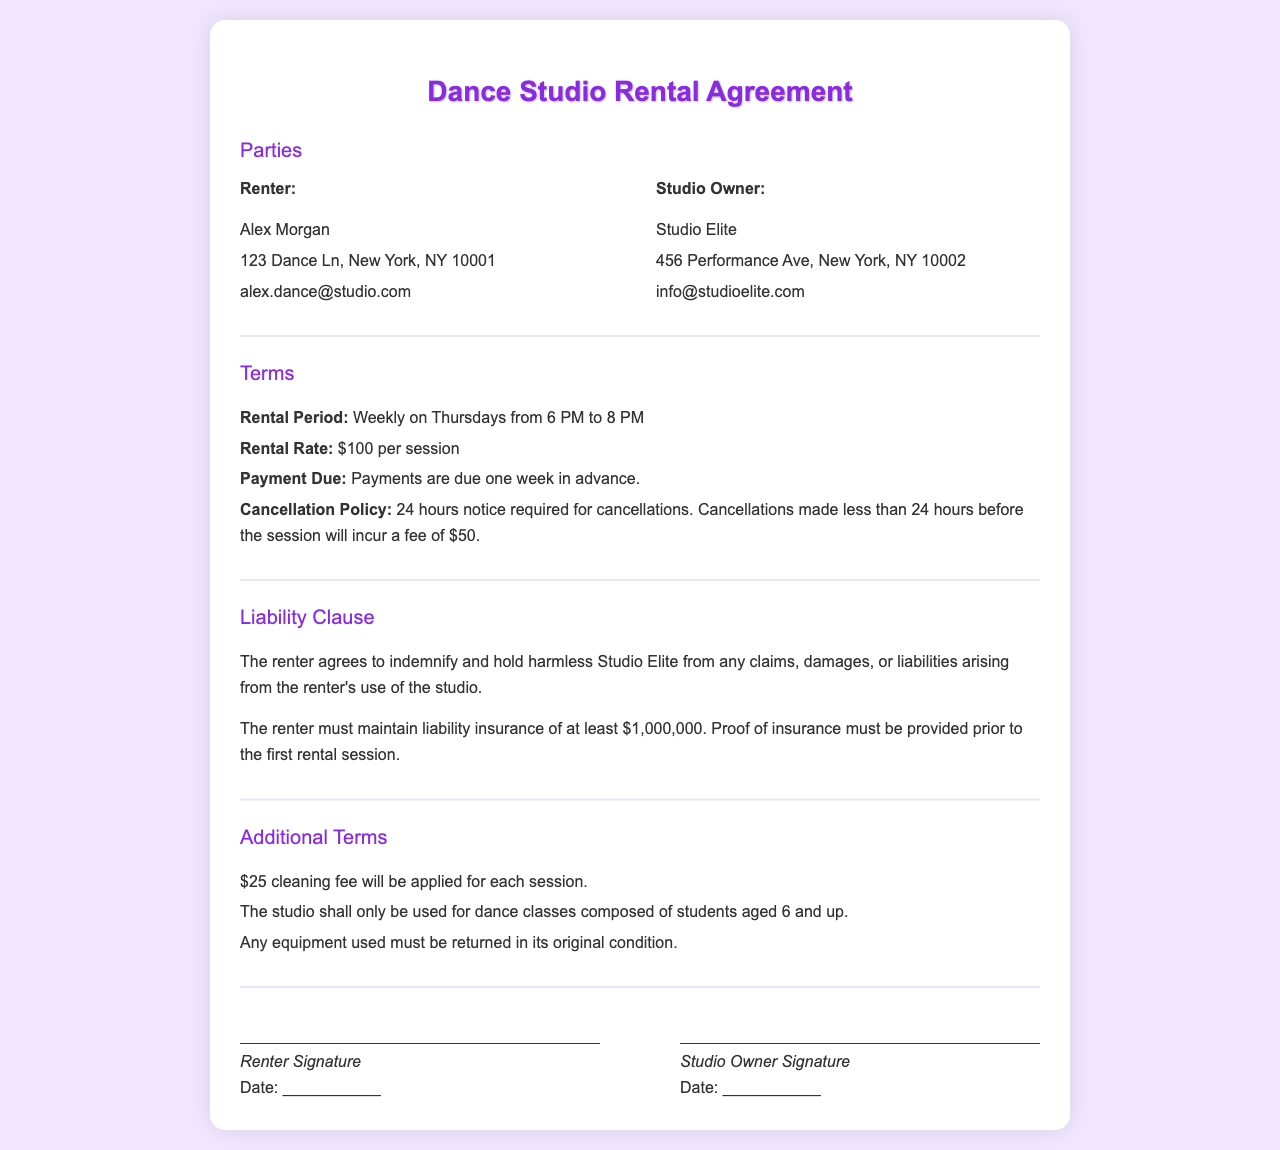what is the rental period? The rental period is specified as weekly on Thursdays from 6 PM to 8 PM.
Answer: weekly on Thursdays from 6 PM to 8 PM what is the rental rate per session? The rental rate mentioned in the document is $100 for each session.
Answer: $100 who is the renter? The document specifies Alex Morgan as the renter.
Answer: Alex Morgan what is the cancellation policy? The policy states that 24 hours notice is required for cancellations, and fees apply for late cancellations.
Answer: 24 hours notice required what is the liability insurance requirement? The renter must maintain liability insurance of at least $1,000,000 as stated in the liability clause.
Answer: $1,000,000 what fee is applied for cleaning? The document mentions a $25 cleaning fee for each session.
Answer: $25 how much notice is needed for cancellations? The cancellation policy requires 24 hours notice for cancellations.
Answer: 24 hours what is the age requirement for students? The document states that the studio is to be used for students aged 6 and up.
Answer: 6 and up who must sign the agreement? The agreement requires signatures from both the renter and the studio owner.
Answer: Renter and Studio Owner 